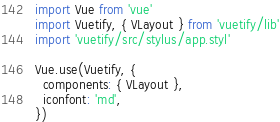Convert code to text. <code><loc_0><loc_0><loc_500><loc_500><_JavaScript_>import Vue from 'vue'
import Vuetify, { VLayout } from 'vuetify/lib'
import 'vuetify/src/stylus/app.styl'

Vue.use(Vuetify, {
  components: { VLayout },
  iconfont: 'md',
})
</code> 